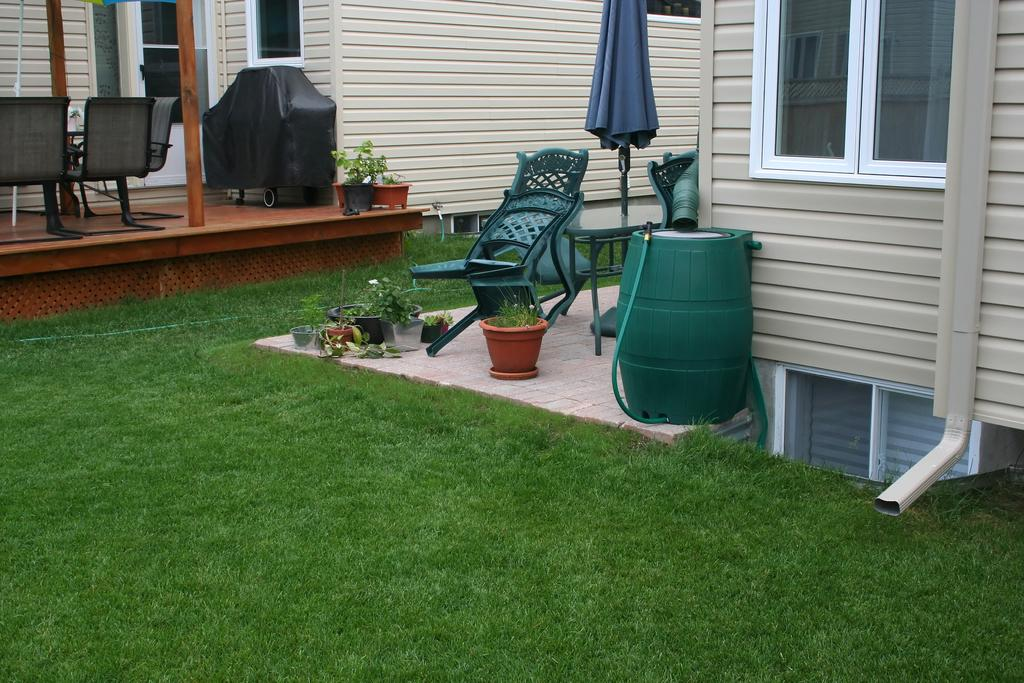What type of vegetation is present in the image? There is grass in the image. What type of structure can be seen in the image? There is a building in the image. What objects are used for planting in the image? There are flower pots in the image. What musical instrument is visible in the image? There is a drum in the image. What type of furniture is present in the image? There are chairs and a table in the image. How many friends are singing songs together in the image? There are no friends or songs present in the image. What is the wish of the person in the image? There is no person or wish mentioned in the image. 